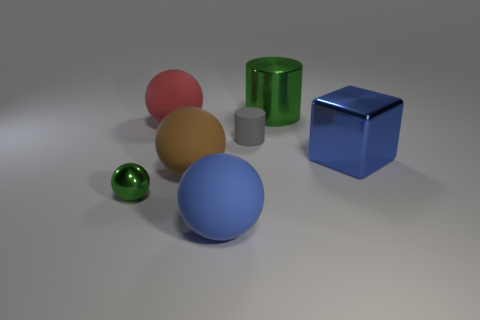Is there a big red object left of the shiny object on the right side of the green object that is right of the big brown ball? There is no big red object to the left of the shiny object; rather, a blue cube is located to the right of the green shiny cylinder, which itself is to the right of a big brown sphere. 